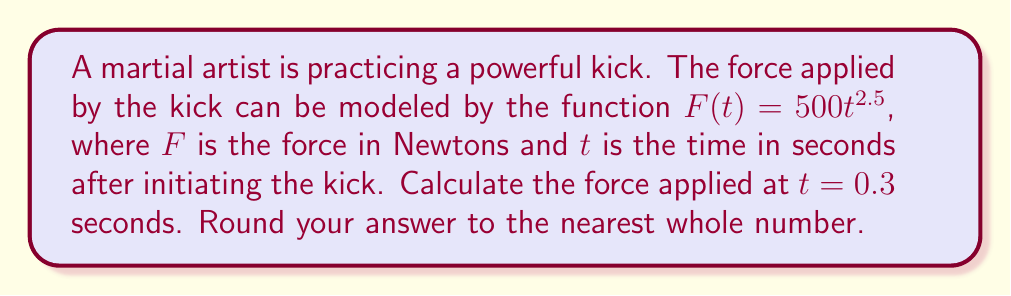What is the answer to this math problem? To solve this problem, we need to evaluate the given power function at $t = 0.3$ seconds. Let's break it down step-by-step:

1) The given function is $F(t) = 500t^{2.5}$

2) We need to calculate $F(0.3)$

3) Substitute $t = 0.3$ into the function:
   $F(0.3) = 500(0.3)^{2.5}$

4) Now, let's evaluate $(0.3)^{2.5}$:
   $$(0.3)^{2.5} = \sqrt{(0.3)^5} = \sqrt{0.00243} \approx 0.0492742$$

5) Multiply this by 500:
   $$500 \times 0.0492742 = 24.6371$$

6) Rounding to the nearest whole number:
   $24.6371 \approx 25$

Therefore, the force applied at $t = 0.3$ seconds is approximately 25 Newtons.
Answer: 25 Newtons 